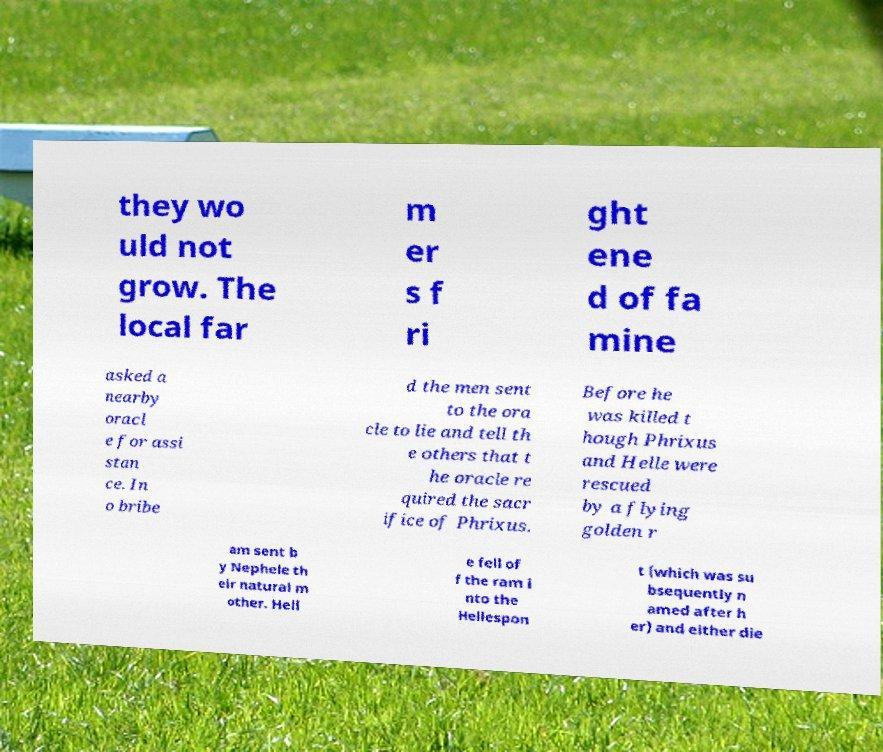For documentation purposes, I need the text within this image transcribed. Could you provide that? they wo uld not grow. The local far m er s f ri ght ene d of fa mine asked a nearby oracl e for assi stan ce. In o bribe d the men sent to the ora cle to lie and tell th e others that t he oracle re quired the sacr ifice of Phrixus. Before he was killed t hough Phrixus and Helle were rescued by a flying golden r am sent b y Nephele th eir natural m other. Hell e fell of f the ram i nto the Hellespon t (which was su bsequently n amed after h er) and either die 